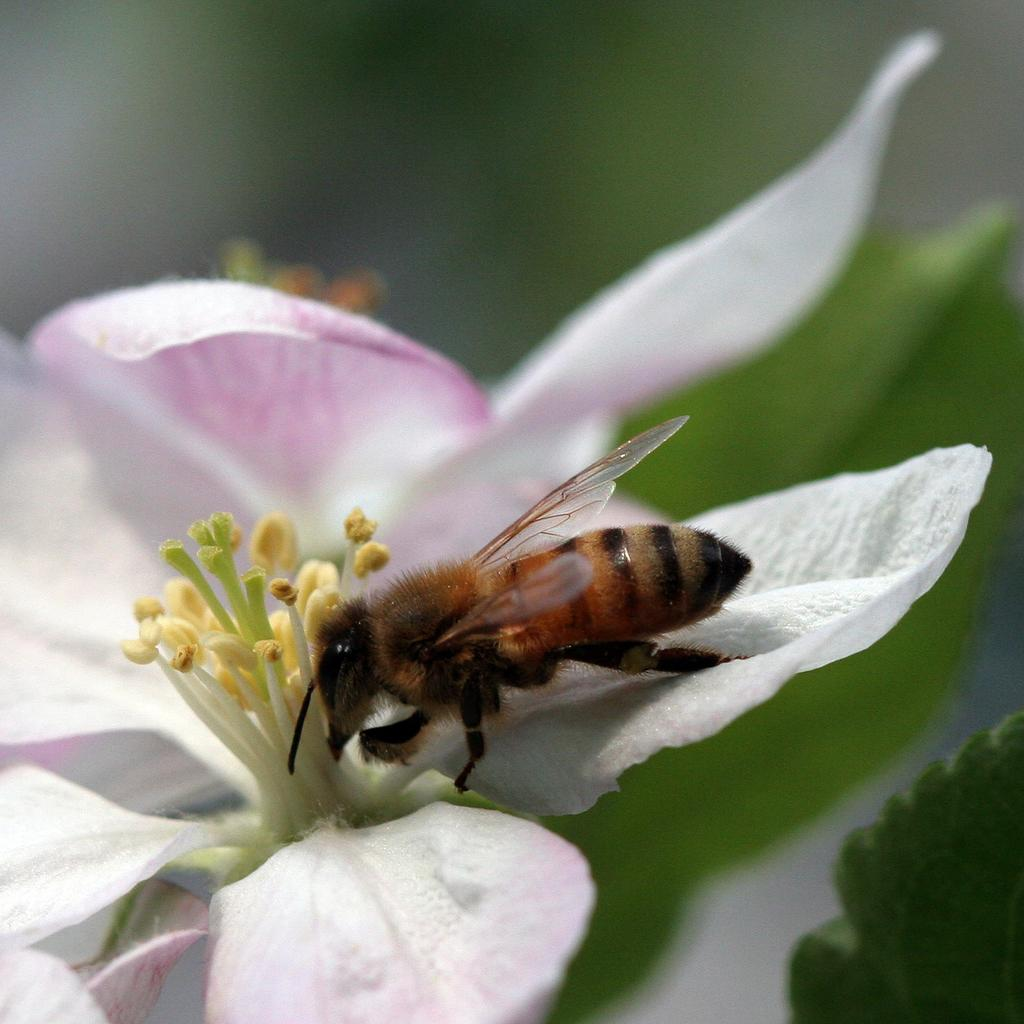What is the main subject of the image? There is a bee in the image. Where is the bee located in the image? The bee is on a flower. What can be seen in the background of the image? There are leaves visible in the background of the image. What type of balloon is the bee holding in the image? There is no balloon present in the image; the bee is on a flower. How does the bee contribute to the building's structural integrity in the image? There is no building present in the image, and the bee is not involved in any construction or structural support. 